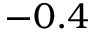Convert formula to latex. <formula><loc_0><loc_0><loc_500><loc_500>- 0 . 4</formula> 